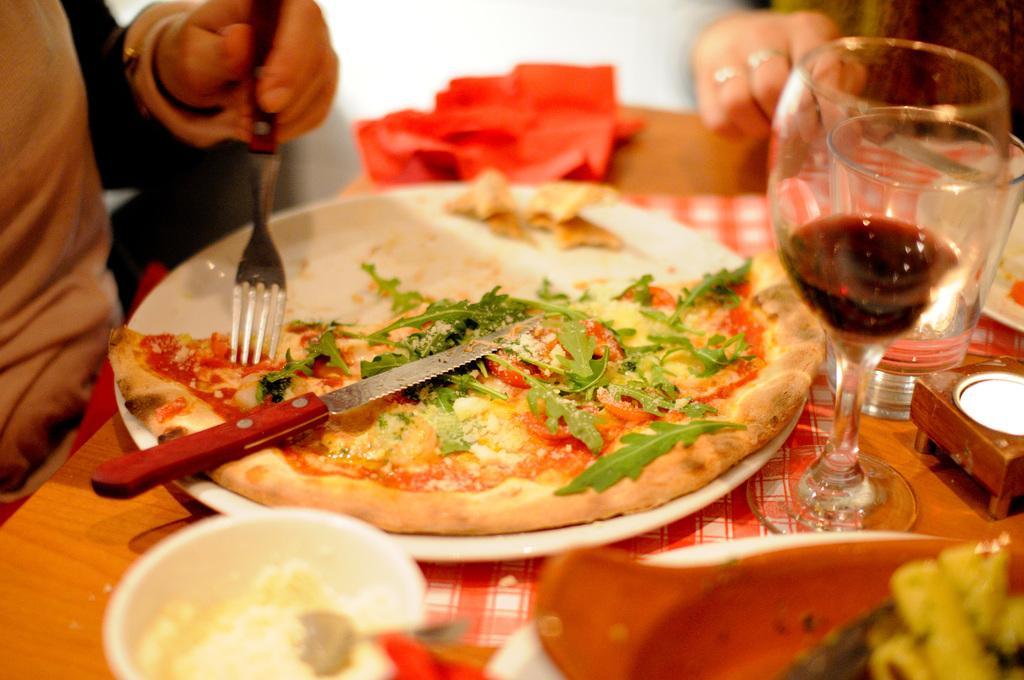Please provide a concise description of this image. In this image I can see a table and on it I can see a plate, few glasses, a bowl, one more plate, a cloth and few other things. On the one plate I can see half pizza and a knife. I can also see two persons and I can see one of them is holding a fork and one is holding a knife. 